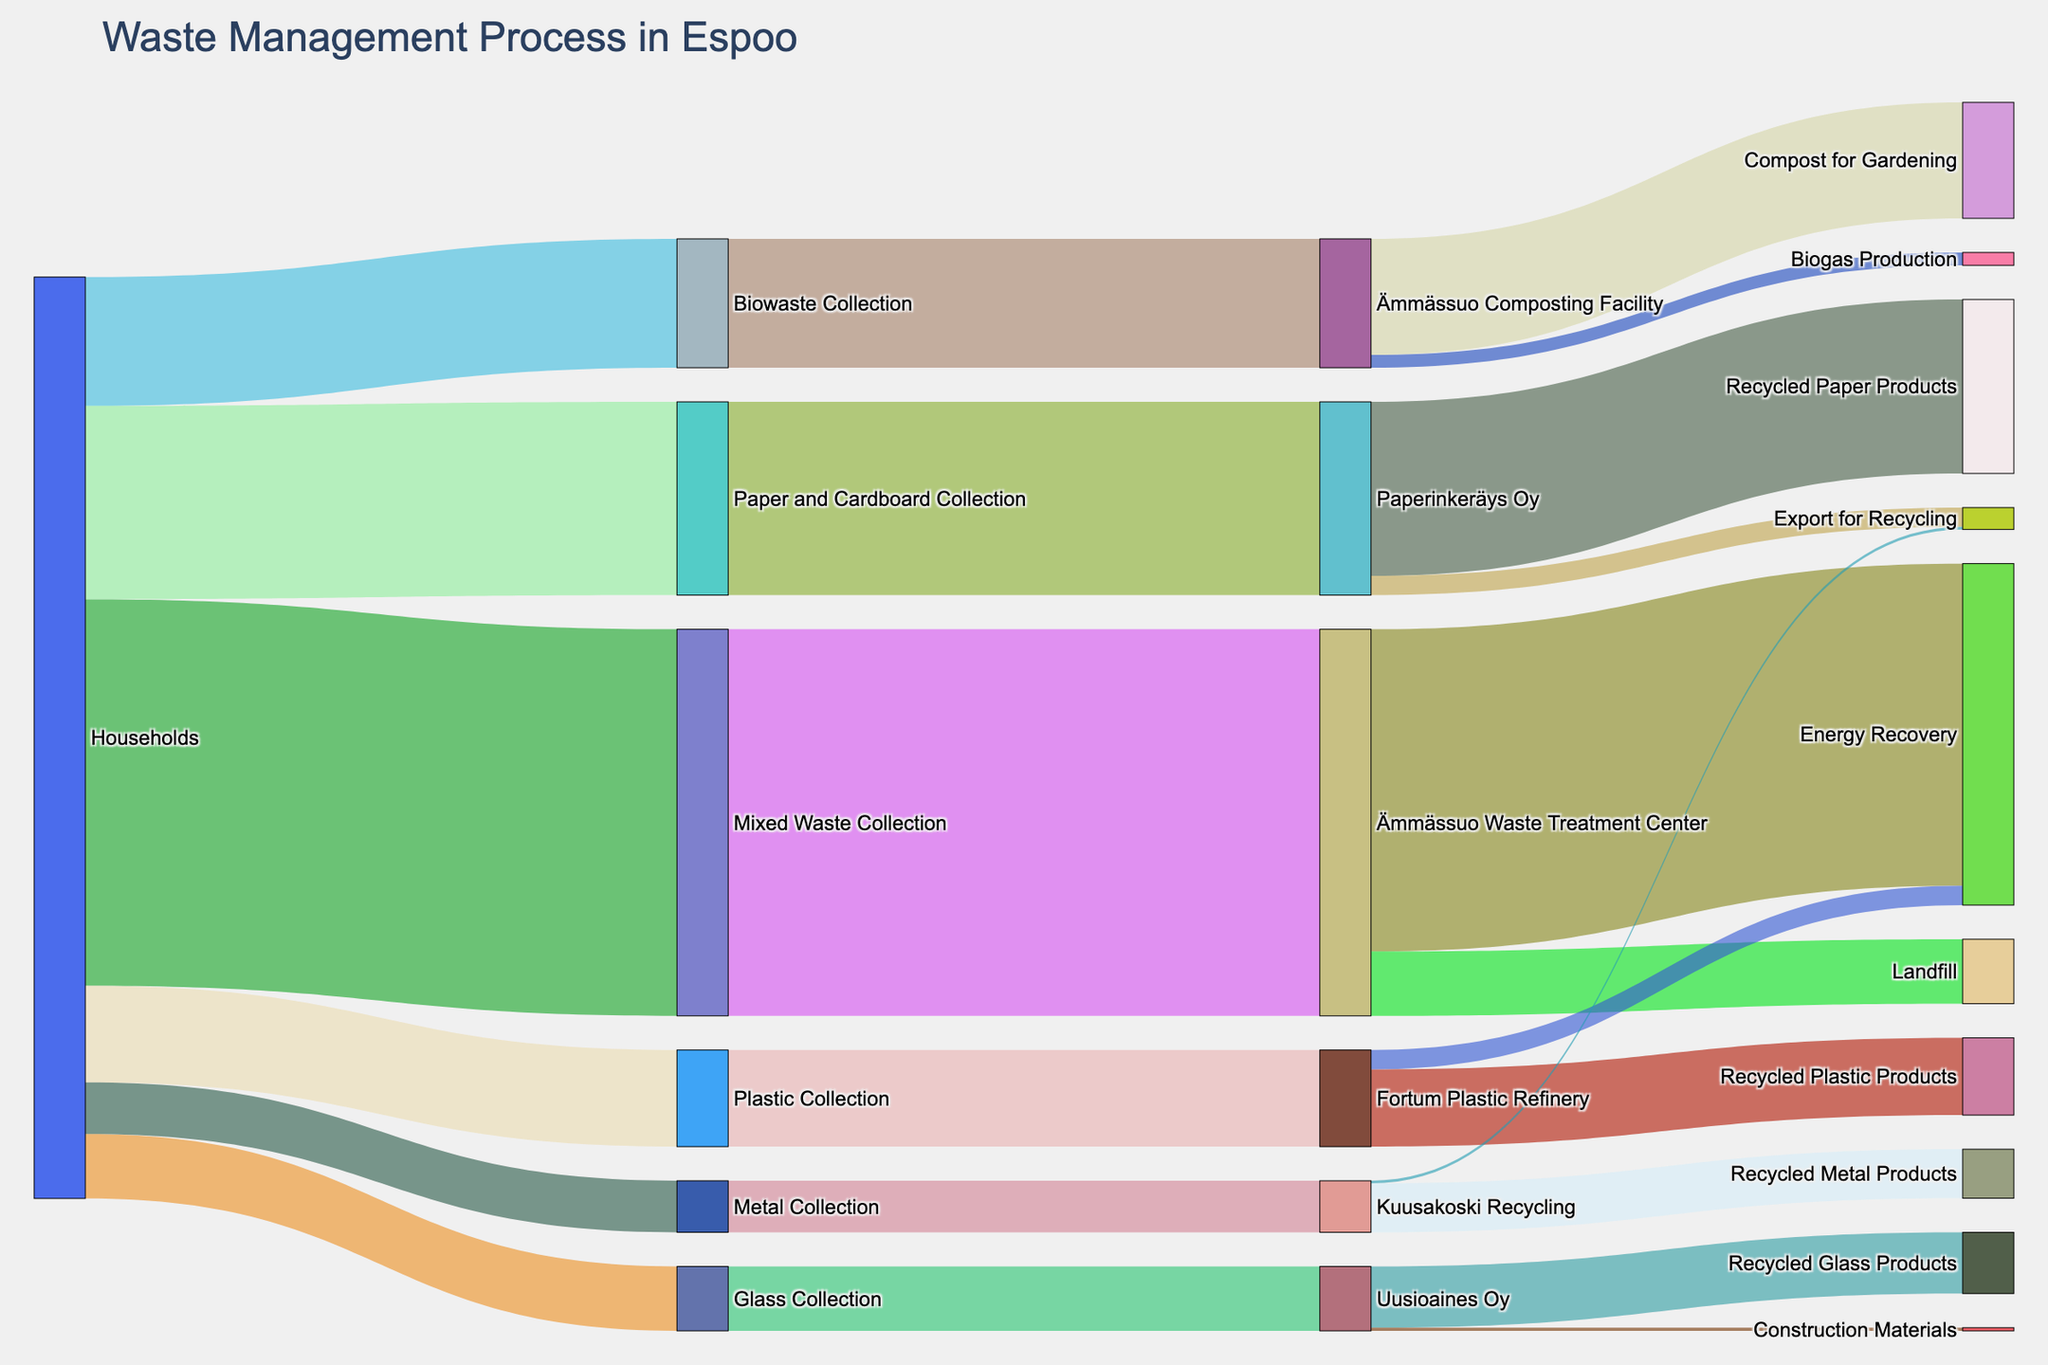What is the main title of the Sankey diagram? The main title is located at the top of the Sankey diagram, usually in a larger and bolder font compared to other texts. It provides an overall description of the diagram's content.
Answer: Waste Management Process in Espoo What type of waste has the highest collection volume from households? To identify this, trace the widest link originating from "Households" to its immediate target. The widths of these links represent the volumes of different waste types. The "Mixed Waste Collection" has the widest link.
Answer: Mixed Waste How much mixed waste goes to the landfill? Find the link that connects "Ämmässuo Waste Treatment Center" to "Landfill" and refer to the value stated on it.
Answer: 1000 Which collection streams contribute to energy recovery at the Ämmässuo Waste Treatment Center? Identify all links that end in the "Energy Recovery" node starting from "Ämmässuo Waste Treatment Center".
Answer: Mixed Waste Collection How much biowaste is used for biogas production? Look for the link from "Ämmässuo Composting Facility" to "Biogas Production" and refer to the value on that link.
Answer: 200 What is the total amount of waste collected from households? Sum the values of all the links originating from "Households" to different collection streams: 6000 + 2000 + 3000 + 1500 + 1000 + 800.
Answer: 14300 What proportion of biowaste collected is used for compost for gardening? Refer to the links from "Ämmässuo Composting Facility" to its targets. Calculate the proportion as (1800 / 2000 * 100).
Answer: 90% Compare the recycling outputs of Paperinkeräys Oy and Fortum Plastic Refinery. Which one has a higher output? Look at the sum of outputs from "Paperinkeräys Oy" (2700 + 300) and "Fortum Plastic Refinery" (1200 + 300). Paperinkeräys Oy has a higher output.
Answer: Paperinkeräys Oy How does the value for recycled glass products compare with recycled metal products? Refer to the specific links for "Recycled Glass Products" (950) and "Recycled Metal Products" (760) and directly compare their values.
Answer: Recycled Glass Products are higher What percentage of the mixed waste collected is recovered as energy? Find the value of mixed waste directed to "Energy Recovery" and divide it by the total collected mixed waste, then multiply by 100: (5000/6000 * 100).
Answer: 83.33% 